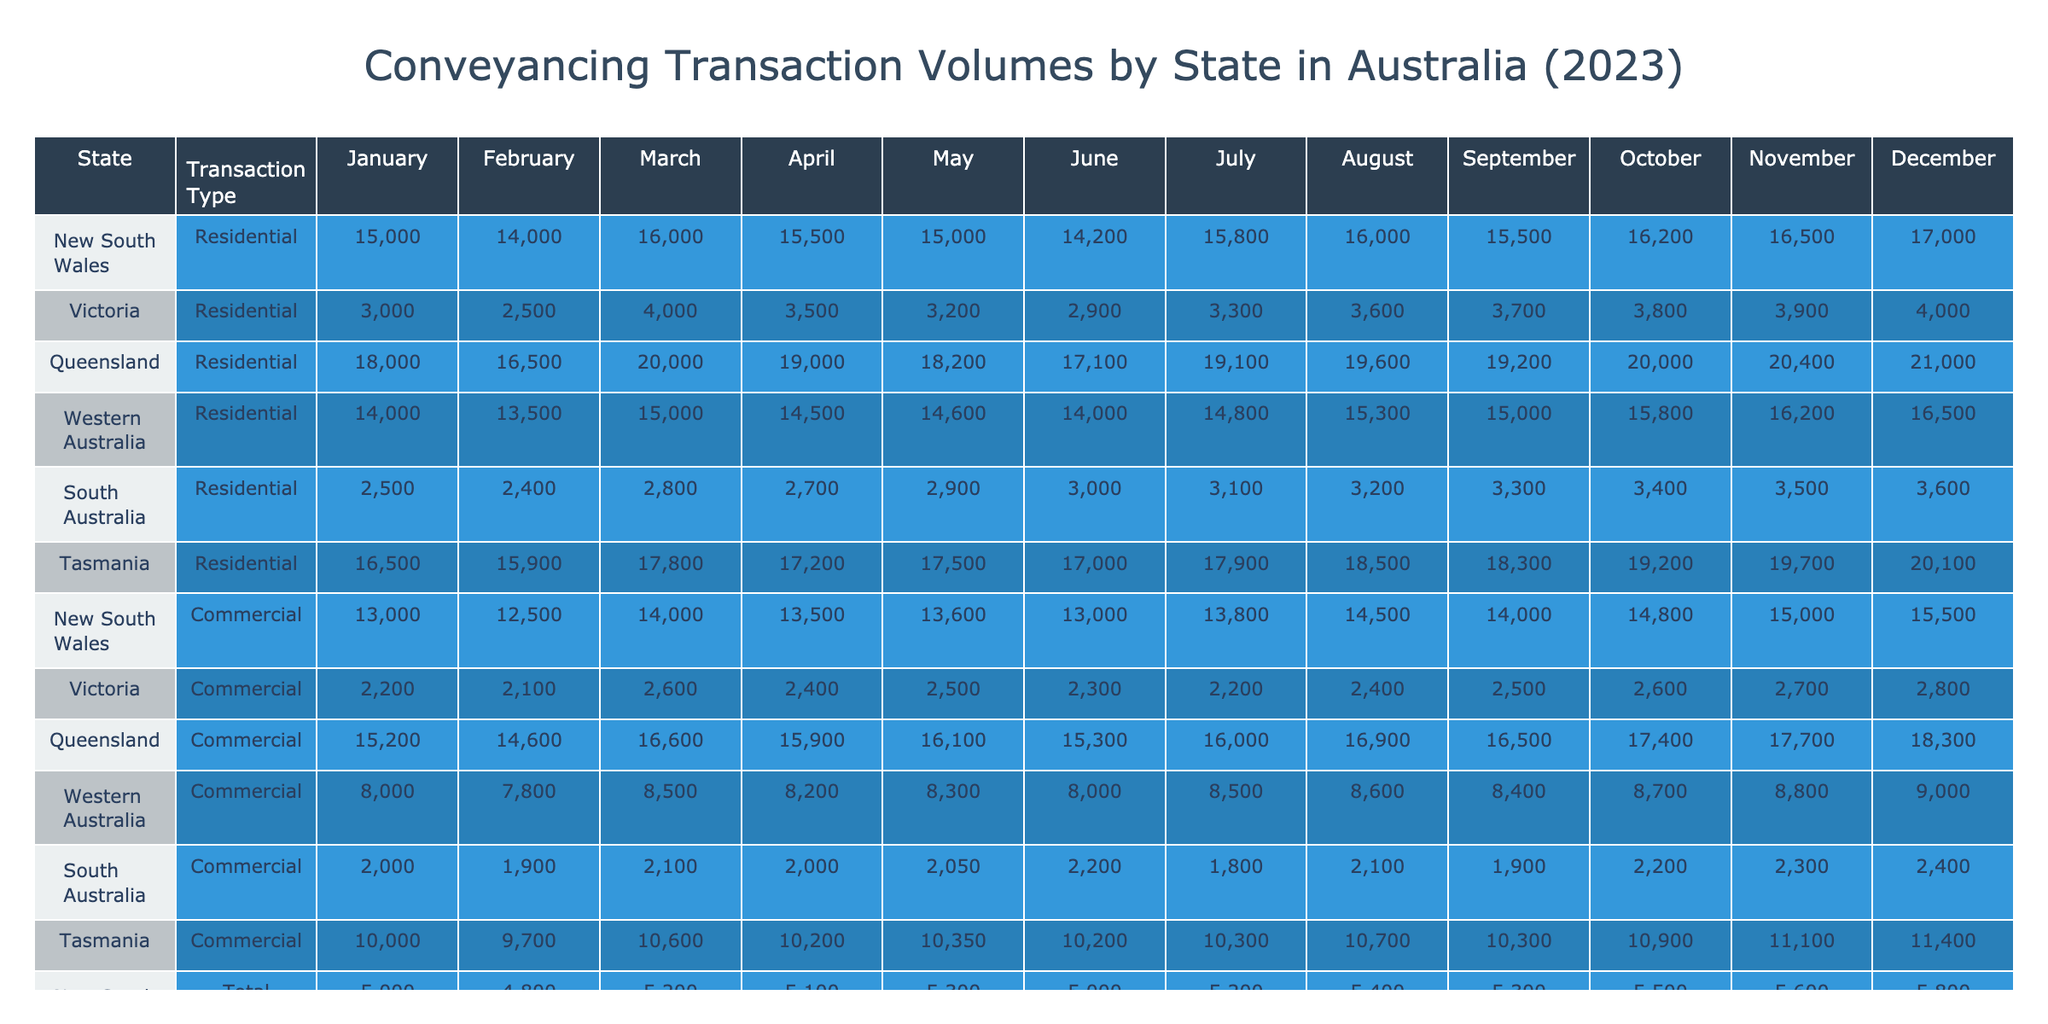What was the total number of conveyancing transactions in Victoria for December 2023? In December, the total transactions in Victoria are listed as 20,100.
Answer: 20,100 Which state had the highest average transaction value in October 2023? In October, New South Wales had the highest average transaction value of AUD 1,000,000, compared to other states.
Answer: New South Wales What is the percentage increase in residential transactions in Queensland from January to December 2023? In January, Queensland had 13,000 residential transactions, and in December, it had 15,500. The increase is (15,500 - 13,000) / 13,000 * 100 = 19.23%.
Answer: 19.23% In which month did South Australia have its highest total transactions, and what was that value? The highest total transactions for South Australia occurred in December with a total of 7,100.
Answer: December, 7,100 What is the average number of commercial transactions across all states for the month of March? For March, the commercial transactions are: NSW (4,000), Victoria (2,800), Queensland (2,600), WA (2,100), SA (1,200), and Tasmania (550). The sum is 13,250, and with 6 states, the average is 13,250 / 6 = 2,208.33.
Answer: 2,208.33 Did Tasmania have more total transactions than South Australia in July 2023? In July, Tasmania had 3,520 total transactions while South Australia had 6,100. Thus, Tasmania had fewer total transactions than South Australia.
Answer: No What is the difference in average transaction value between New South Wales and Western Australia in December 2023? In December, New South Wales had an average transaction value of AUD 1,010,000, and Western Australia had AUD 650,000. The difference is 1,010,000 - 650,000 = 360,000.
Answer: 360,000 Which state consistently had the lowest number of residential transactions from January to December 2023? South Australia had consistently lower residential transactions compared to other states, with a maximum of 5,800 in December, which is the lowest peak among the states.
Answer: South Australia How many total transactions were conducted in Queensland for the entire year of 2023? To find the total, sum the transactions for each month in Queensland: 15,200 + 14,600 + 16,600 + 15,900 + 16,100 + 15,300 + 16,000 + 16,900 + 16,500 + 17,400 + 17,700 + 18,300 = 195,100.
Answer: 195,100 Was there an increase in total transactions from January to February in any state? For New South Wales, the total increased from 18,000 in January to 16,500 in February. This indicates a decrease; thus, it shows that not all states experienced an increase during this period.
Answer: No 